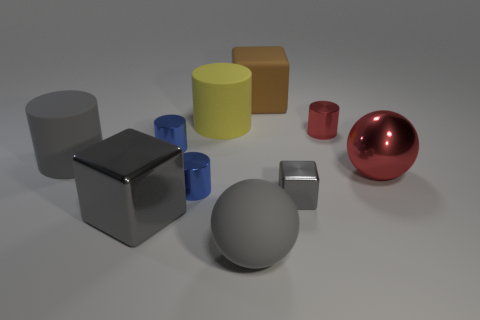Is the number of gray blocks that are behind the brown cube less than the number of rubber balls in front of the tiny red metal thing?
Make the answer very short. Yes. Does the gray cylinder have the same size as the red cylinder?
Keep it short and to the point. No. The gray object that is both right of the yellow cylinder and in front of the small gray cube has what shape?
Make the answer very short. Sphere. How many large gray blocks have the same material as the big yellow thing?
Your response must be concise. 0. There is a red object in front of the red shiny cylinder; what number of yellow matte cylinders are to the right of it?
Keep it short and to the point. 0. There is a rubber object that is in front of the red object in front of the large gray object that is behind the small cube; what is its shape?
Provide a short and direct response. Sphere. What is the size of the other metal cube that is the same color as the large metallic cube?
Offer a very short reply. Small. What number of objects are either big gray things or tiny rubber objects?
Offer a terse response. 3. What color is the shiny block that is the same size as the gray ball?
Ensure brevity in your answer.  Gray. Is the shape of the big brown matte thing the same as the gray metallic object that is on the right side of the big brown matte block?
Your answer should be compact. Yes. 